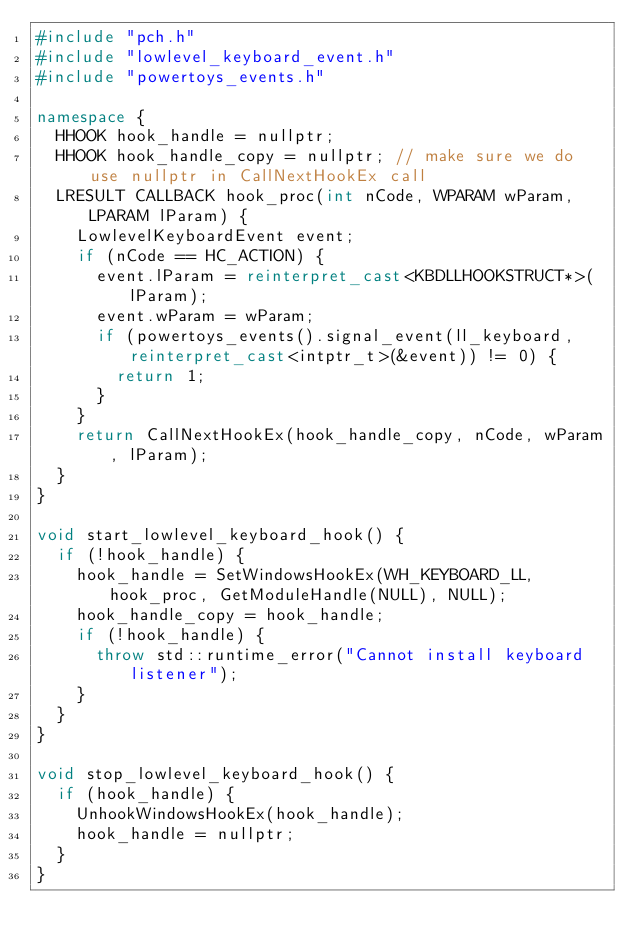<code> <loc_0><loc_0><loc_500><loc_500><_C++_>#include "pch.h"
#include "lowlevel_keyboard_event.h"
#include "powertoys_events.h"

namespace {
  HHOOK hook_handle = nullptr;
  HHOOK hook_handle_copy = nullptr; // make sure we do use nullptr in CallNextHookEx call
  LRESULT CALLBACK hook_proc(int nCode, WPARAM wParam, LPARAM lParam) {
    LowlevelKeyboardEvent event;
    if (nCode == HC_ACTION) {
      event.lParam = reinterpret_cast<KBDLLHOOKSTRUCT*>(lParam);
      event.wParam = wParam;
      if (powertoys_events().signal_event(ll_keyboard, reinterpret_cast<intptr_t>(&event)) != 0) {
        return 1;
      }
    }
    return CallNextHookEx(hook_handle_copy, nCode, wParam, lParam);
  }
}

void start_lowlevel_keyboard_hook() {
  if (!hook_handle) {
    hook_handle = SetWindowsHookEx(WH_KEYBOARD_LL, hook_proc, GetModuleHandle(NULL), NULL);
    hook_handle_copy = hook_handle;
    if (!hook_handle) {
      throw std::runtime_error("Cannot install keyboard listener");
    }
  }
}

void stop_lowlevel_keyboard_hook() {
  if (hook_handle) {
    UnhookWindowsHookEx(hook_handle);
    hook_handle = nullptr;
  }
}
</code> 